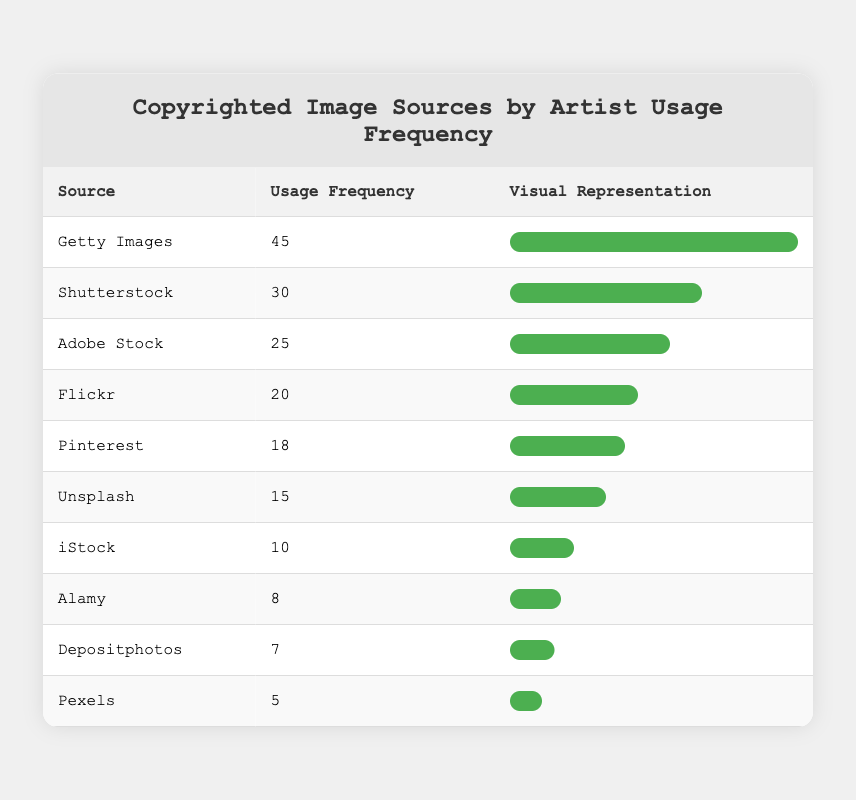What is the highest usage frequency among the image sources? The table shows a list of image sources with their corresponding usage frequencies. By looking at the "Usage Frequency" column, the highest value is 45, corresponding to "Getty Images."
Answer: 45 Which source has a usage frequency of 30? By scanning the table for the "Usage Frequency" column, we can see that "Shutterstock" has a usage frequency of 30.
Answer: Shutterstock What is the difference in usage frequency between Adobe Stock and Flickr? From the table, "Adobe Stock" has a usage frequency of 25, and "Flickr" has a usage frequency of 20. The difference is calculated as 25 - 20 = 5.
Answer: 5 How many sources have a usage frequency of 20 or more? Counting the sources listed with usage frequencies of 20 or more, we find "Getty Images," "Shutterstock," "Adobe Stock," "Flickr," which are 4 sources in total.
Answer: 4 Is it true that Alamy has a higher usage frequency than iStock? Looking at the table, "Alamy" has a usage frequency of 8, while "iStock" has 10. Since 8 is not greater than 10, the statement is false.
Answer: No What is the average usage frequency of the top three sources? To find the average, first sum the usage frequencies of the top three sources: 45 (Getty Images) + 30 (Shutterstock) + 25 (Adobe Stock) = 100. Then divide by 3: 100 / 3 = 33.33.
Answer: 33.33 Which source has the lowest usage frequency? Looking at the usage frequencies in the table, "Pexels" has the lowest frequency at 5.
Answer: Pexels How many sources have a usage frequency below 15? Evaluating the table, we find the following sources below 15: "Unsplash" (15), "iStock" (10), "Alamy" (8), "Depositphotos" (7), and "Pexels" (5), totaling 4 sources.
Answer: 4 What percentage of the highest usage frequency does Pinterest represent? "Pinterest" has a usage frequency of 18 and the highest is 45. The percentage is calculated as (18 / 45) * 100 = 40%.
Answer: 40% 